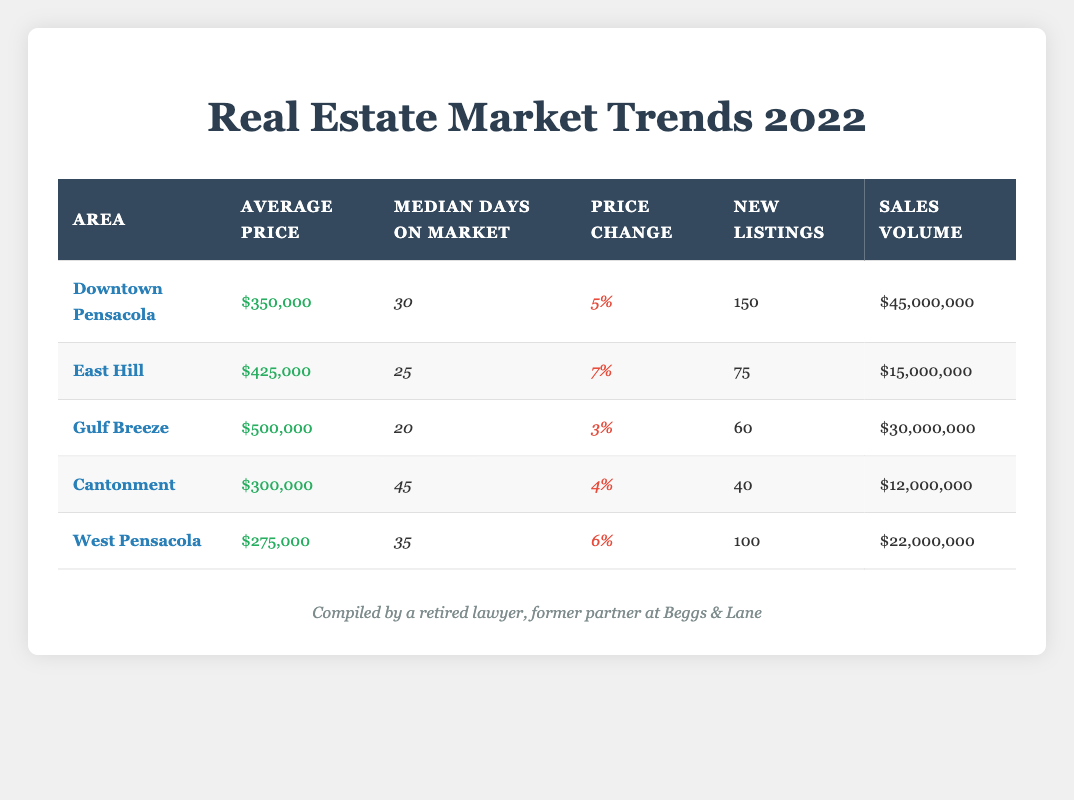What is the average price of homes in Gulf Breeze? From the table, the average price for Gulf Breeze is listed as $500,000.
Answer: $500,000 How many new listings were there in Downtown Pensacola? The table shows that Downtown Pensacola had 150 new listings.
Answer: 150 What is the price change percentage for East Hill? According to the table, East Hill has a price change percentage of 7%.
Answer: 7% Which area had the highest sales volume? By comparing the sales volume values in the table, Downtown Pensacola, with $45,000,000, has the highest sales volume.
Answer: Downtown Pensacola How does the average price in Cantonment compare to the average price in West Pensacola? The average price in Cantonment is $300,000, while West Pensacola is $275,000. The average price in Cantonment is higher than in West Pensacola by $25,000.
Answer: Cantonment is higher by $25,000 What is the median number of days on market for Gulf Breeze and how does it compare to East Hill? Gulf Breeze has 20 median days on the market and East Hill has 25. Gulf Breeze has 5 fewer days on the market than East Hill.
Answer: Gulf Breeze has 5 fewer days Is the average price in West Pensacola higher than the average price in Cantonment? The average price in West Pensacola is $275,000, while in Cantonment it is $300,000. Thus, West Pensacola's average price is not higher than Cantonment's.
Answer: No If you sum the new listings from all areas, what is the total? Adding the new listings: 150 + 75 + 60 + 40 + 100 = 425. The total new listings across all areas is 425.
Answer: 425 What is the overall price change percentage for all areas combined? To find the overall price change percentage, you would take the individual areas' percentages into account proportionally based on their average prices and listings, but that calculation isn't directly possible from the table data.
Answer: Calculation requires more data Which area has the lowest average price and what is it? By examining the average prices listed, West Pensacola has the lowest average price at $275,000.
Answer: West Pensacola; $275,000 How many more days on the market does Cantonment have compared to Gulf Breeze? Cantonment has 45 days on the market while Gulf Breeze has 20. The difference is 45 - 20 = 25 days.
Answer: 25 days more 